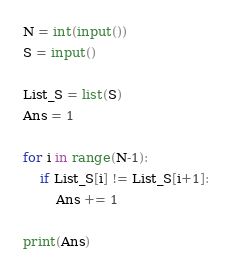<code> <loc_0><loc_0><loc_500><loc_500><_Python_>N = int(input())
S = input()

List_S = list(S)
Ans = 1

for i in range(N-1):
    if List_S[i] != List_S[i+1]:
        Ans += 1
    
print(Ans)
</code> 